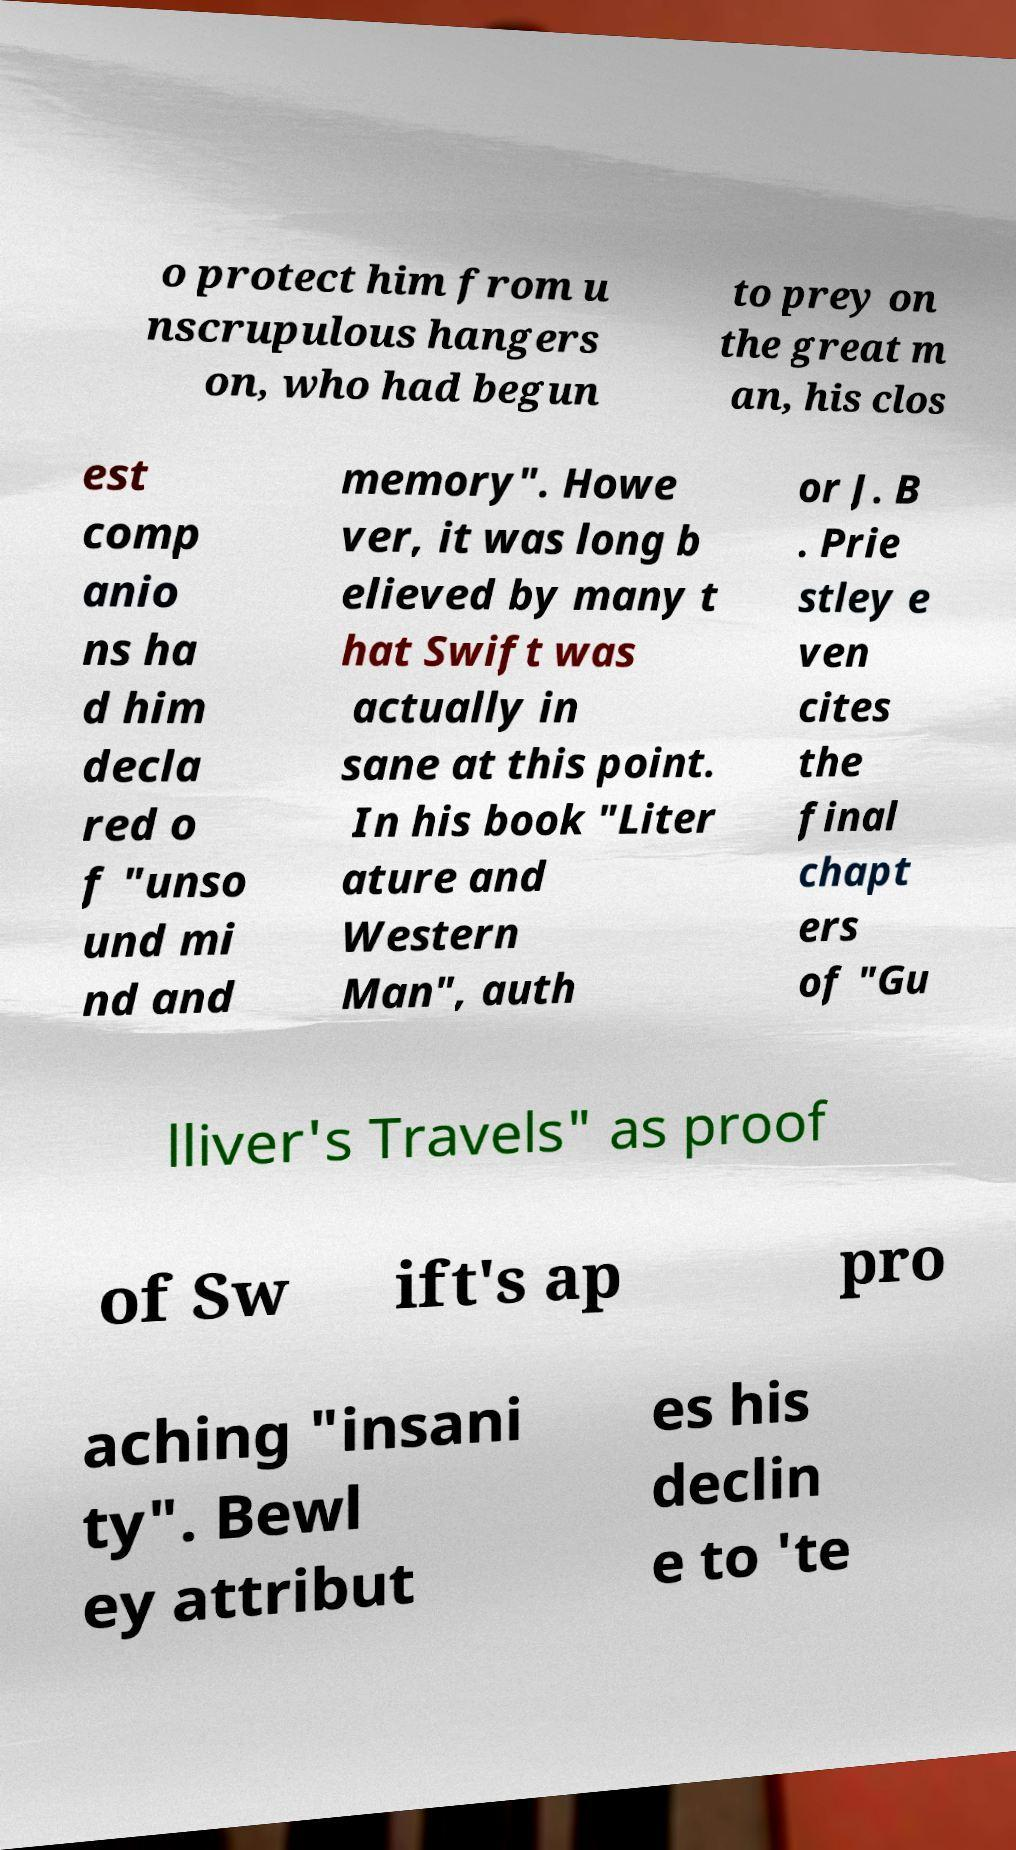Could you assist in decoding the text presented in this image and type it out clearly? o protect him from u nscrupulous hangers on, who had begun to prey on the great m an, his clos est comp anio ns ha d him decla red o f "unso und mi nd and memory". Howe ver, it was long b elieved by many t hat Swift was actually in sane at this point. In his book "Liter ature and Western Man", auth or J. B . Prie stley e ven cites the final chapt ers of "Gu lliver's Travels" as proof of Sw ift's ap pro aching "insani ty". Bewl ey attribut es his declin e to 'te 